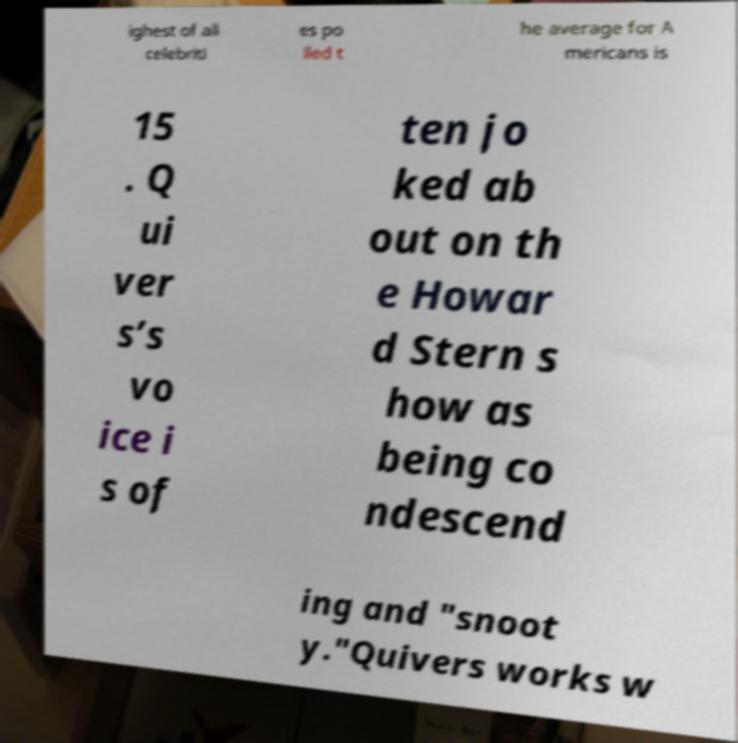Please identify and transcribe the text found in this image. ighest of all celebriti es po lled t he average for A mericans is 15 . Q ui ver s’s vo ice i s of ten jo ked ab out on th e Howar d Stern s how as being co ndescend ing and "snoot y."Quivers works w 